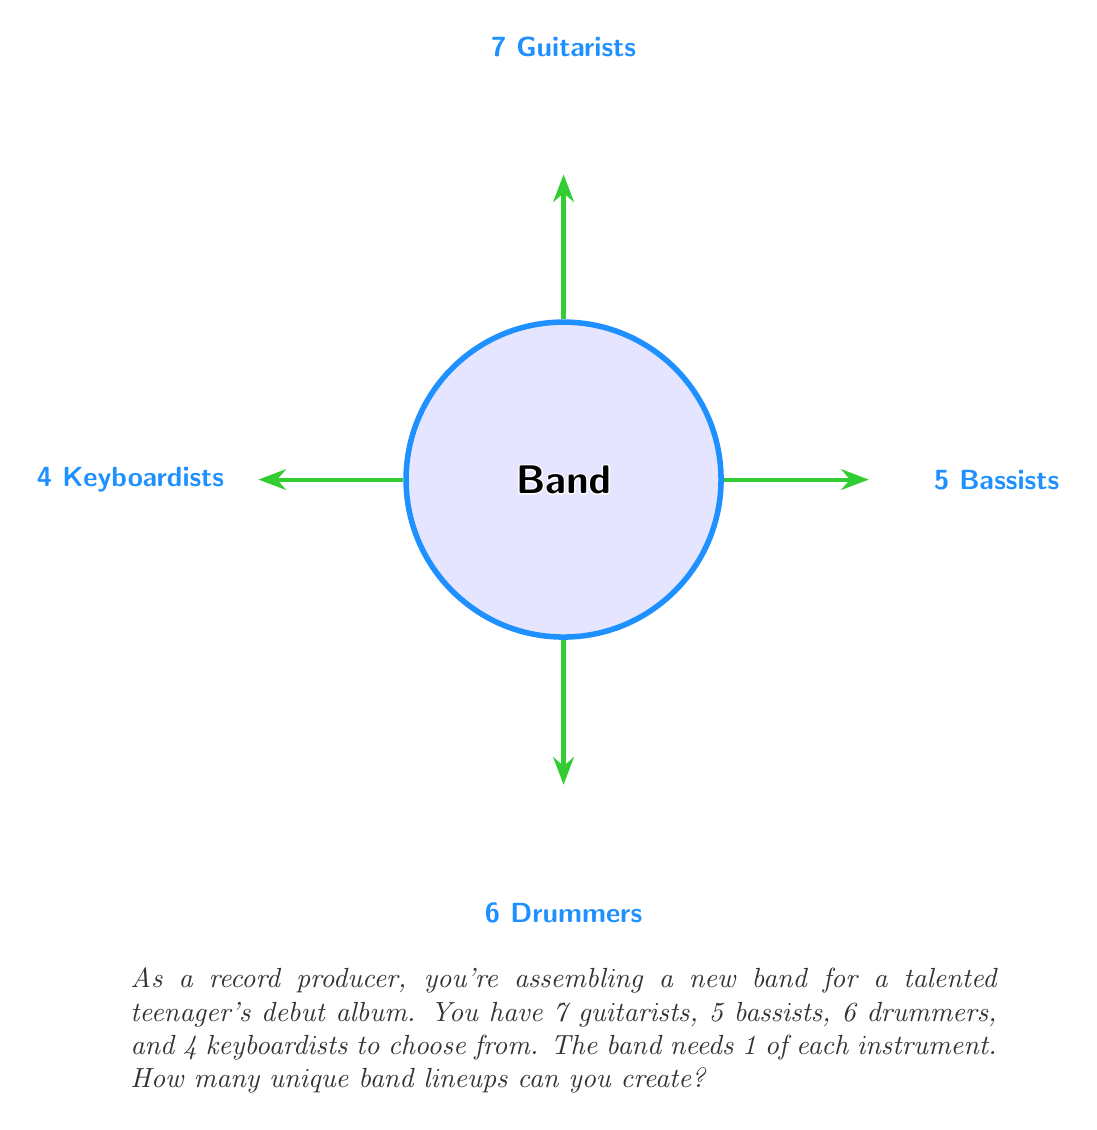Can you solve this math problem? Let's approach this step-by-step using the multiplication principle of counting:

1) For each instrument, we are selecting 1 musician from the available options:
   - 1 guitarist from 7 options
   - 1 bassist from 5 options
   - 1 drummer from 6 options
   - 1 keyboardist from 4 options

2) For each position, the selection is independent of the others. This means we multiply the number of choices for each position.

3) The total number of possible combinations is therefore:

   $$ 7 \times 5 \times 6 \times 4 $$

4) Let's calculate this:
   $$ 7 \times 5 = 35 $$
   $$ 35 \times 6 = 210 $$
   $$ 210 \times 4 = 840 $$

Therefore, there are 840 possible unique band lineups.

This calculation demonstrates the fundamental counting principle: if we have $m$ ways of doing something and $n$ ways of doing another thing, there are $m \times n$ ways of doing both things.
Answer: 840 